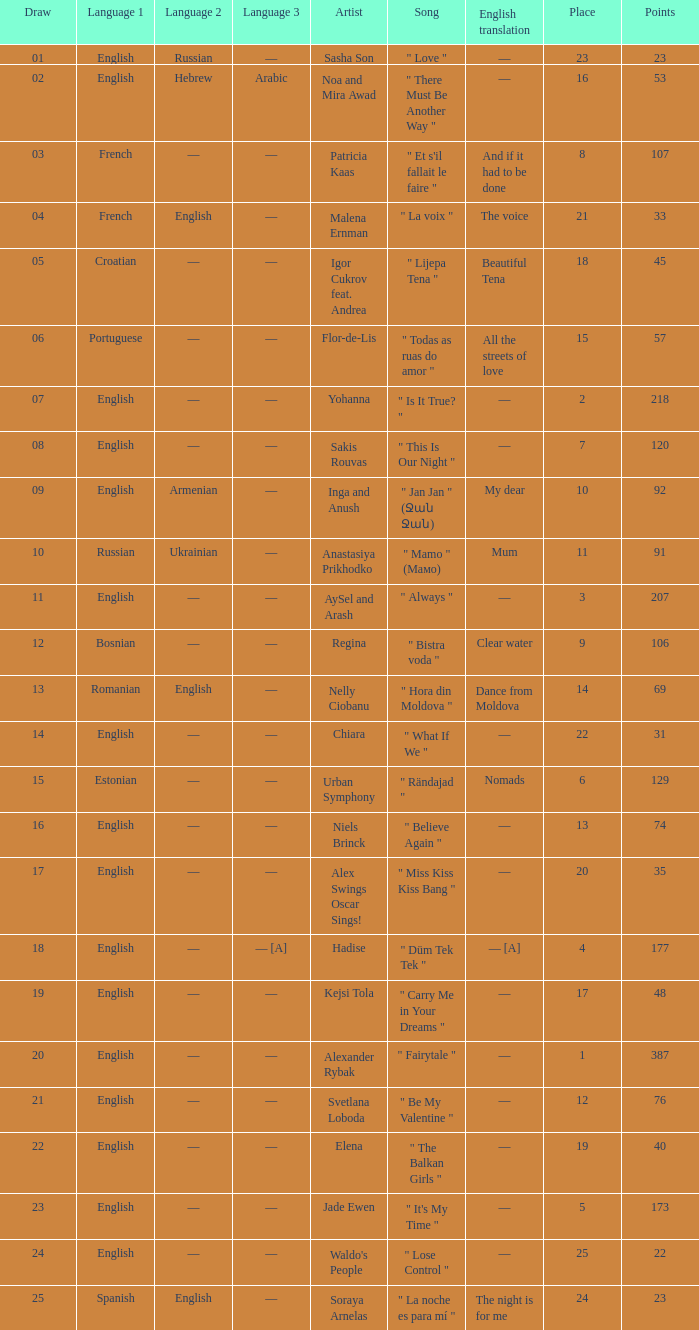What song was in french? " Et s'il fallait le faire ". 